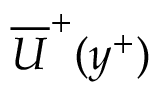<formula> <loc_0><loc_0><loc_500><loc_500>\overline { U } ^ { + } ( y ^ { + } )</formula> 